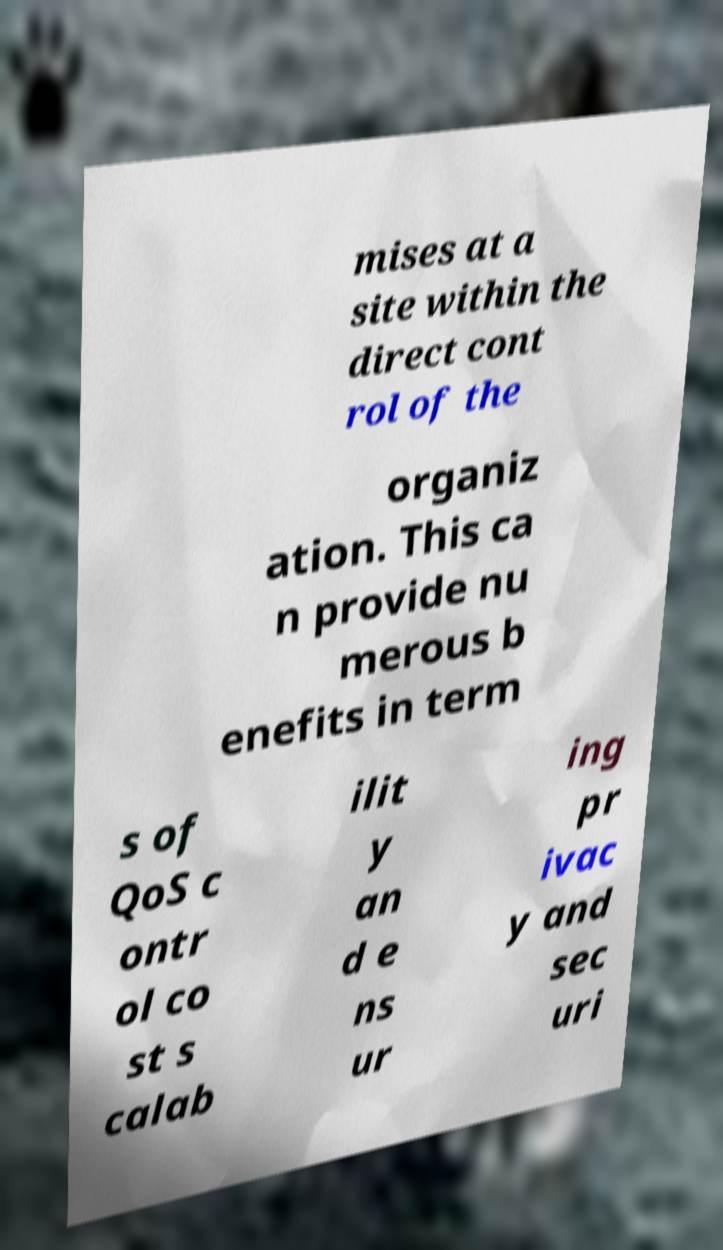Could you assist in decoding the text presented in this image and type it out clearly? mises at a site within the direct cont rol of the organiz ation. This ca n provide nu merous b enefits in term s of QoS c ontr ol co st s calab ilit y an d e ns ur ing pr ivac y and sec uri 